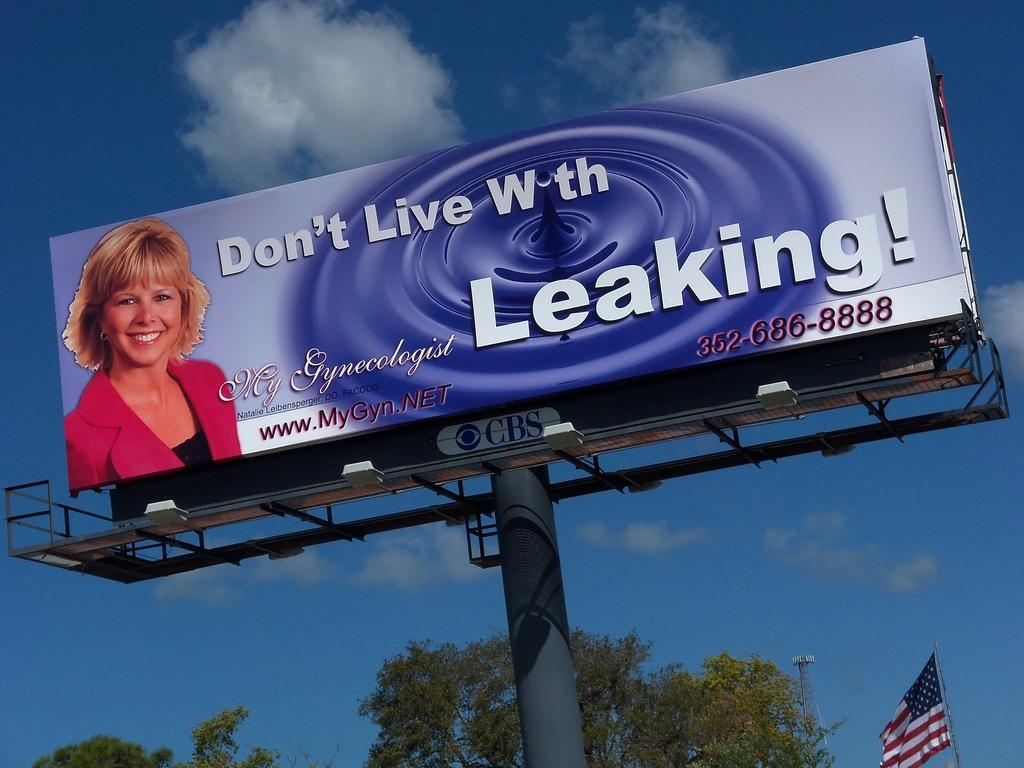Provide a one-sentence caption for the provided image. A sign with a blond lady advertising a gynecologist. 